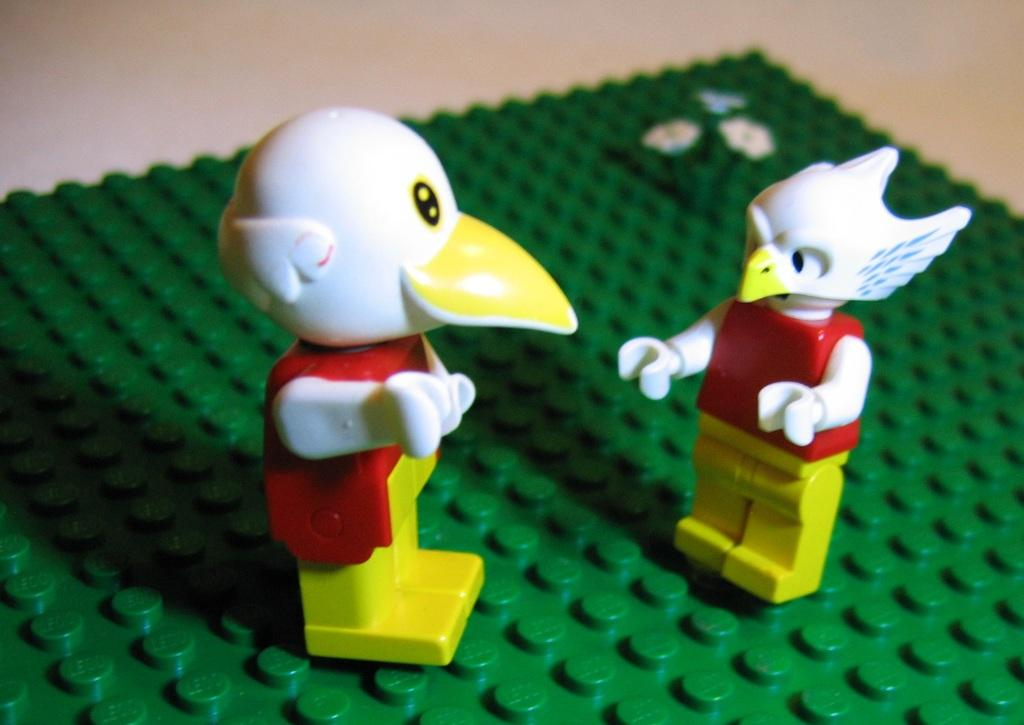How many toys are visible in the image? There are two toys in the image. What is the color of the object on which the toys are placed? The object is green. What caption is written on the toys in the image? There is no caption written on the toys in the image. What type of railway is visible in the image? There is no railway present in the image. 